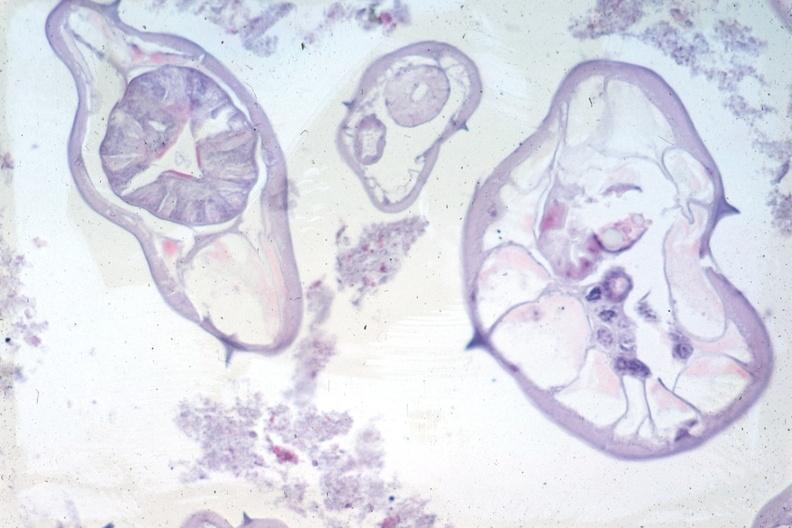s peritoneum present?
Answer the question using a single word or phrase. No 